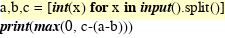Convert code to text. <code><loc_0><loc_0><loc_500><loc_500><_Python_>a,b,c = [int(x) for x in input().split()]
print(max(0, c-(a-b)))
</code> 